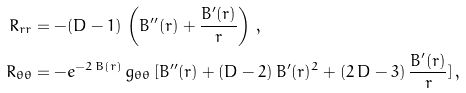Convert formula to latex. <formula><loc_0><loc_0><loc_500><loc_500>R _ { r r } & = - ( D - 1 ) \, \left ( B ^ { \prime \prime } ( r ) + \frac { B ^ { \prime } ( r ) } { r } \right ) \, , \\ R _ { \theta \theta } & = - e ^ { - 2 \, B ( r ) } \, g _ { \theta \theta } \, [ B ^ { \prime \prime } ( r ) + ( D - 2 ) \, B ^ { \prime } ( r ) ^ { 2 } + ( 2 \, D - 3 ) \, \frac { B ^ { \prime } ( r ) } { r } ] \, ,</formula> 